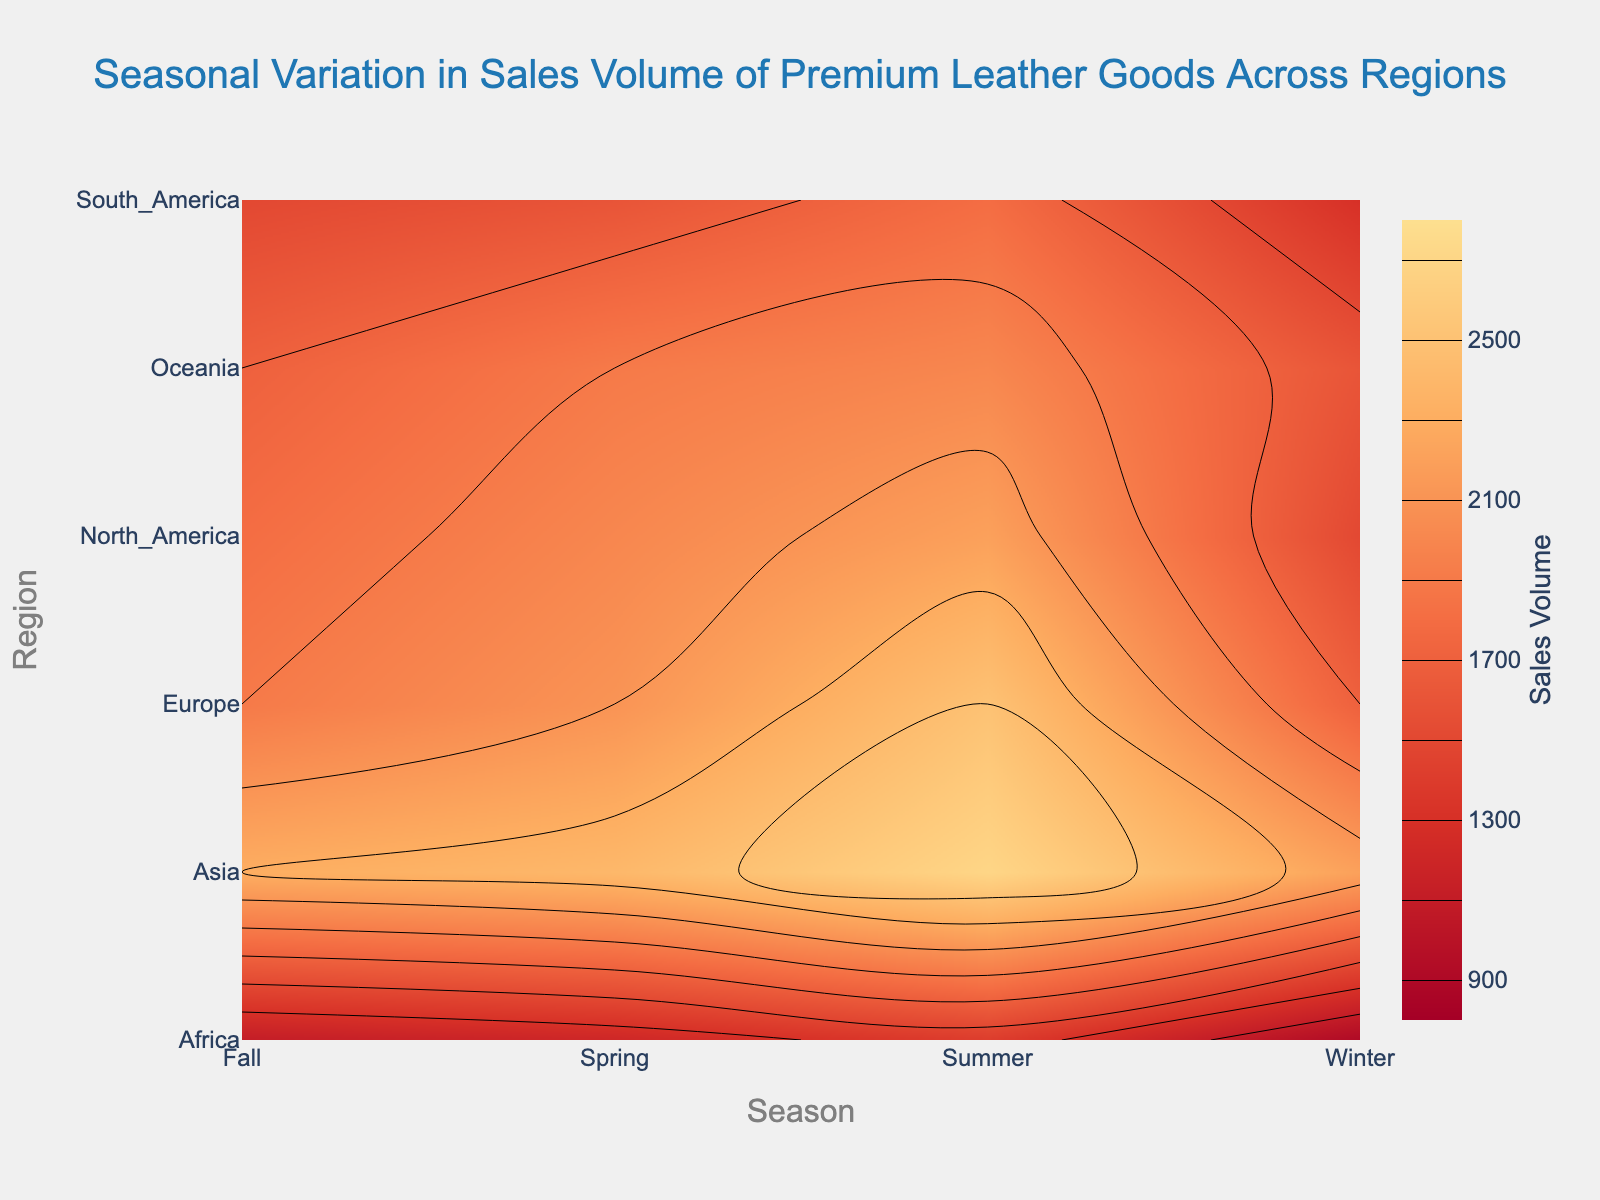what's the title of the plot? The title is typically displayed at the top of the plot. The title of this plot is "Seasonal Variation in Sales Volume of Premium Leather Goods Across Regions."
Answer: Seasonal Variation in Sales Volume of Premium Leather Goods Across Regions what is the sales volume range the contour plot covers? The plot's color bar indicates the range of the sales volume values, colored from the minimum to the maximum. By examining the color bar, the range is from 900 to 2700.
Answer: 900 to 2700 which season has the highest sales volume in Asia? By locating Asia on the Y-axis and examining the color intensity corresponding to each season, summer shows the highest value.
Answer: summer which region shows the lowest sales volume in the winter season? By navigating to the point where Winter and the various regions intersect and identifying the color that indicates the lowest value, it's clear that Africa has the lowest sales volume in winter.
Answer: Africa what's the average sales volume in Europe throughout the seasons? Sum the sales volumes for Europe across all seasons (1700+2100+2500+1900=8200) and divide by the number of seasons (4).
Answer: 2050 which two regions show the most similar sales volumes in the fall? By examining the sales volume in fall for each region and comparing the values, it's evident that North America and Oceania both show a sales volume around 1700-1800, indicating they are most similar.
Answer: North America and Oceania how does the sales volume in South America in summer compare to Europe in winter? Locate the sales volume for South America in summer (1800) and Europe in winter (1700) and compare the values.
Answer: South America is higher which season experiences the highest overall sales volume across all regions? By identifying the season with the most intense color (indicating the highest sales volume when compared across all regions), Summer clearly stands out as the highest.
Answer: summer what is the difference in sales volume between Asia in spring and North America in fall? Determine the sales volumes for Asia in spring (2400) and North America in fall (1800), then subtract the latter from the former (2400-1800).
Answer: 600 which region has the most significant variance in sales volumes across the seasons? By comparing the differences in the highest and lowest sales volumes for each region across all seasons, one can observe that Asia has a wide range (900-2700), indicating the most significant variance.
Answer: Asia 